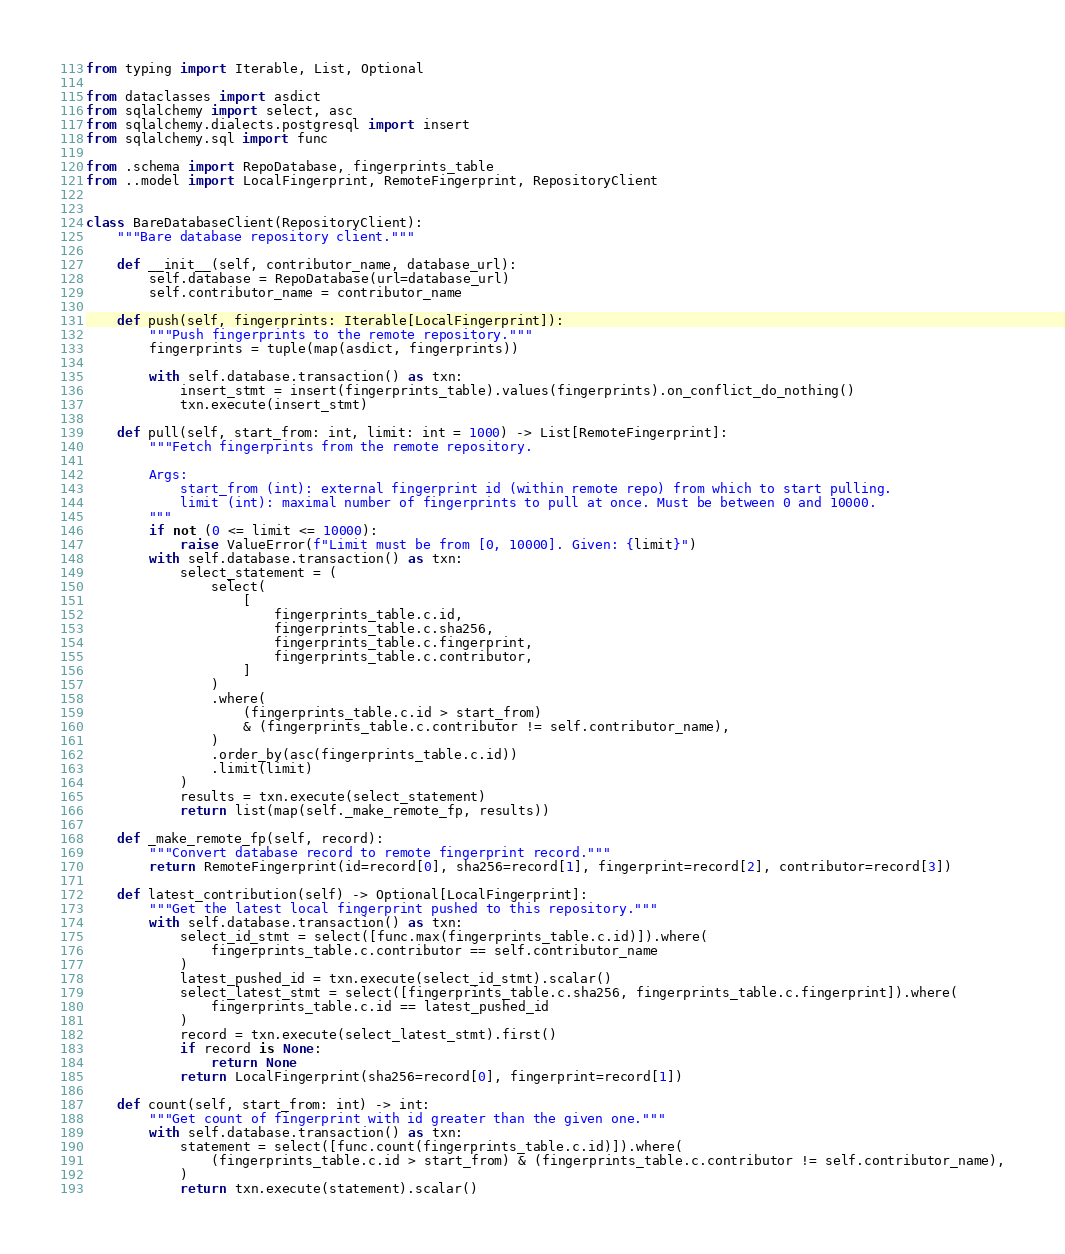Convert code to text. <code><loc_0><loc_0><loc_500><loc_500><_Python_>from typing import Iterable, List, Optional

from dataclasses import asdict
from sqlalchemy import select, asc
from sqlalchemy.dialects.postgresql import insert
from sqlalchemy.sql import func

from .schema import RepoDatabase, fingerprints_table
from ..model import LocalFingerprint, RemoteFingerprint, RepositoryClient


class BareDatabaseClient(RepositoryClient):
    """Bare database repository client."""

    def __init__(self, contributor_name, database_url):
        self.database = RepoDatabase(url=database_url)
        self.contributor_name = contributor_name

    def push(self, fingerprints: Iterable[LocalFingerprint]):
        """Push fingerprints to the remote repository."""
        fingerprints = tuple(map(asdict, fingerprints))

        with self.database.transaction() as txn:
            insert_stmt = insert(fingerprints_table).values(fingerprints).on_conflict_do_nothing()
            txn.execute(insert_stmt)

    def pull(self, start_from: int, limit: int = 1000) -> List[RemoteFingerprint]:
        """Fetch fingerprints from the remote repository.

        Args:
            start_from (int): external fingerprint id (within remote repo) from which to start pulling.
            limit (int): maximal number of fingerprints to pull at once. Must be between 0 and 10000.
        """
        if not (0 <= limit <= 10000):
            raise ValueError(f"Limit must be from [0, 10000]. Given: {limit}")
        with self.database.transaction() as txn:
            select_statement = (
                select(
                    [
                        fingerprints_table.c.id,
                        fingerprints_table.c.sha256,
                        fingerprints_table.c.fingerprint,
                        fingerprints_table.c.contributor,
                    ]
                )
                .where(
                    (fingerprints_table.c.id > start_from)
                    & (fingerprints_table.c.contributor != self.contributor_name),
                )
                .order_by(asc(fingerprints_table.c.id))
                .limit(limit)
            )
            results = txn.execute(select_statement)
            return list(map(self._make_remote_fp, results))

    def _make_remote_fp(self, record):
        """Convert database record to remote fingerprint record."""
        return RemoteFingerprint(id=record[0], sha256=record[1], fingerprint=record[2], contributor=record[3])

    def latest_contribution(self) -> Optional[LocalFingerprint]:
        """Get the latest local fingerprint pushed to this repository."""
        with self.database.transaction() as txn:
            select_id_stmt = select([func.max(fingerprints_table.c.id)]).where(
                fingerprints_table.c.contributor == self.contributor_name
            )
            latest_pushed_id = txn.execute(select_id_stmt).scalar()
            select_latest_stmt = select([fingerprints_table.c.sha256, fingerprints_table.c.fingerprint]).where(
                fingerprints_table.c.id == latest_pushed_id
            )
            record = txn.execute(select_latest_stmt).first()
            if record is None:
                return None
            return LocalFingerprint(sha256=record[0], fingerprint=record[1])

    def count(self, start_from: int) -> int:
        """Get count of fingerprint with id greater than the given one."""
        with self.database.transaction() as txn:
            statement = select([func.count(fingerprints_table.c.id)]).where(
                (fingerprints_table.c.id > start_from) & (fingerprints_table.c.contributor != self.contributor_name),
            )
            return txn.execute(statement).scalar()
</code> 